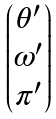Convert formula to latex. <formula><loc_0><loc_0><loc_500><loc_500>\begin{pmatrix} \theta ^ { \prime } \\ \omega ^ { \prime } \\ \pi ^ { \prime } \end{pmatrix}</formula> 